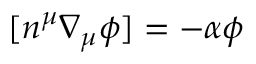<formula> <loc_0><loc_0><loc_500><loc_500>[ n ^ { \mu } \nabla _ { \mu } \phi ] = - \alpha \phi</formula> 